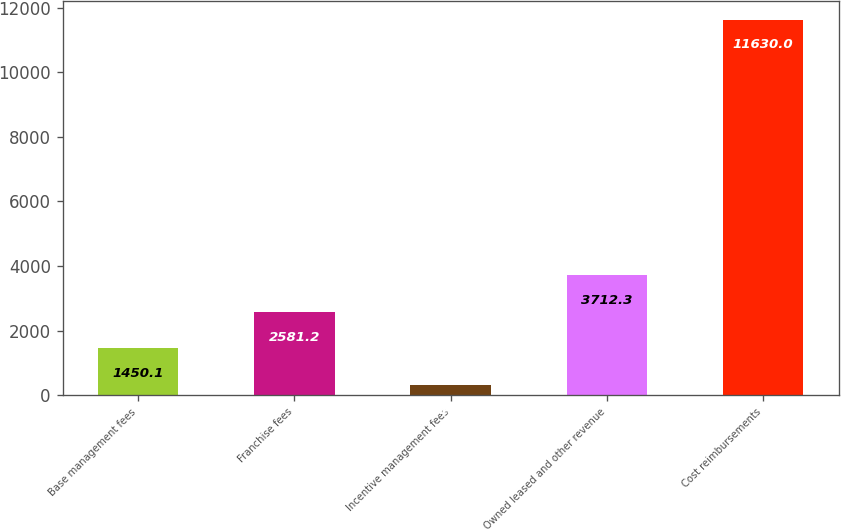<chart> <loc_0><loc_0><loc_500><loc_500><bar_chart><fcel>Base management fees<fcel>Franchise fees<fcel>Incentive management fees<fcel>Owned leased and other revenue<fcel>Cost reimbursements<nl><fcel>1450.1<fcel>2581.2<fcel>319<fcel>3712.3<fcel>11630<nl></chart> 